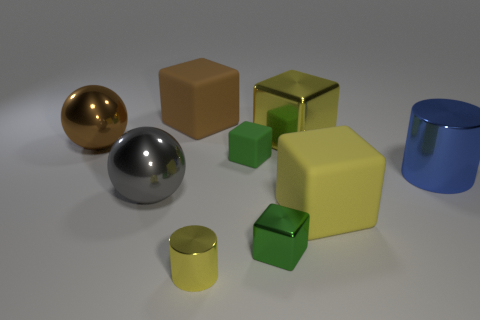Subtract all green balls. How many yellow cubes are left? 2 Subtract all large brown rubber cubes. How many cubes are left? 4 Subtract all brown blocks. How many blocks are left? 4 Subtract all cylinders. How many objects are left? 7 Subtract all blue cubes. Subtract all green cylinders. How many cubes are left? 5 Add 4 metallic objects. How many metallic objects exist? 10 Subtract 0 yellow balls. How many objects are left? 9 Subtract all small green matte objects. Subtract all large brown things. How many objects are left? 6 Add 3 yellow things. How many yellow things are left? 6 